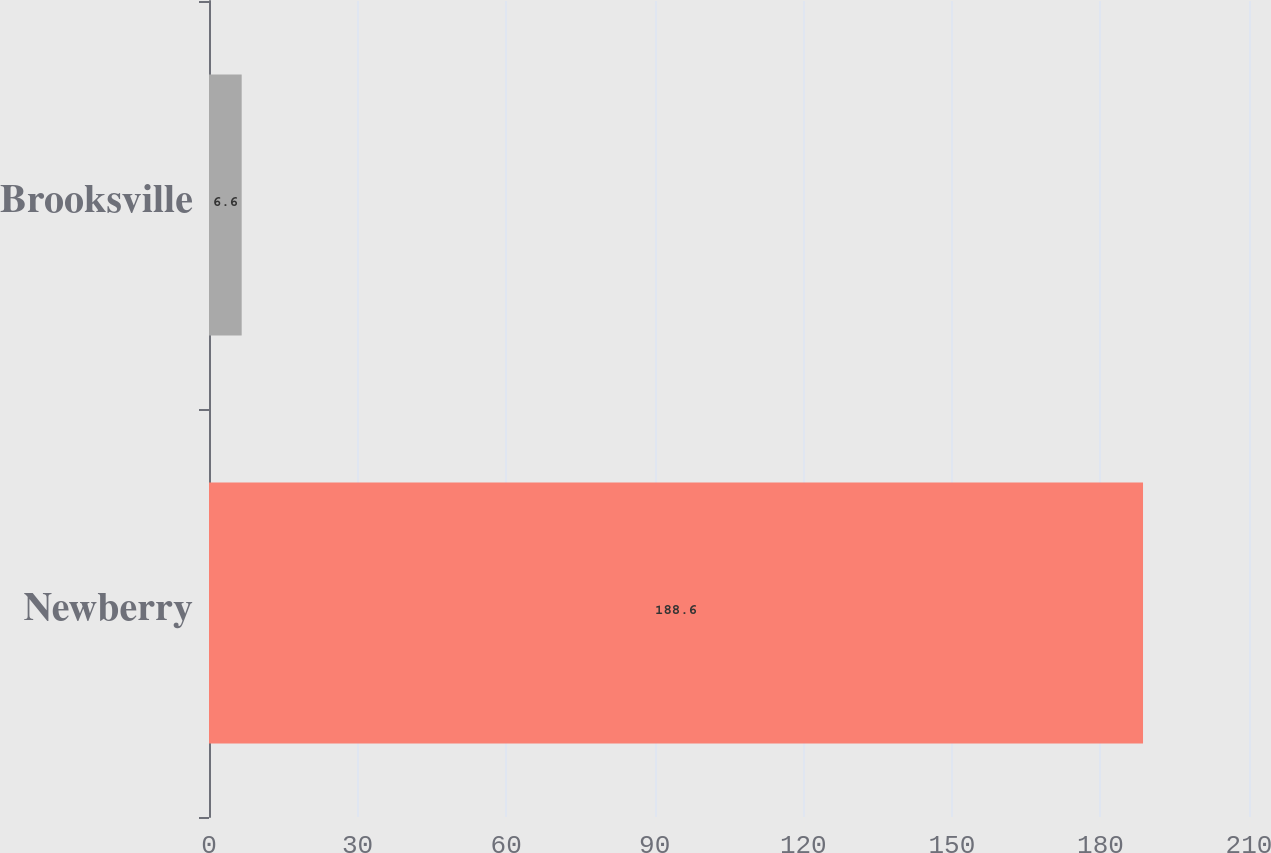Convert chart. <chart><loc_0><loc_0><loc_500><loc_500><bar_chart><fcel>Newberry<fcel>Brooksville<nl><fcel>188.6<fcel>6.6<nl></chart> 